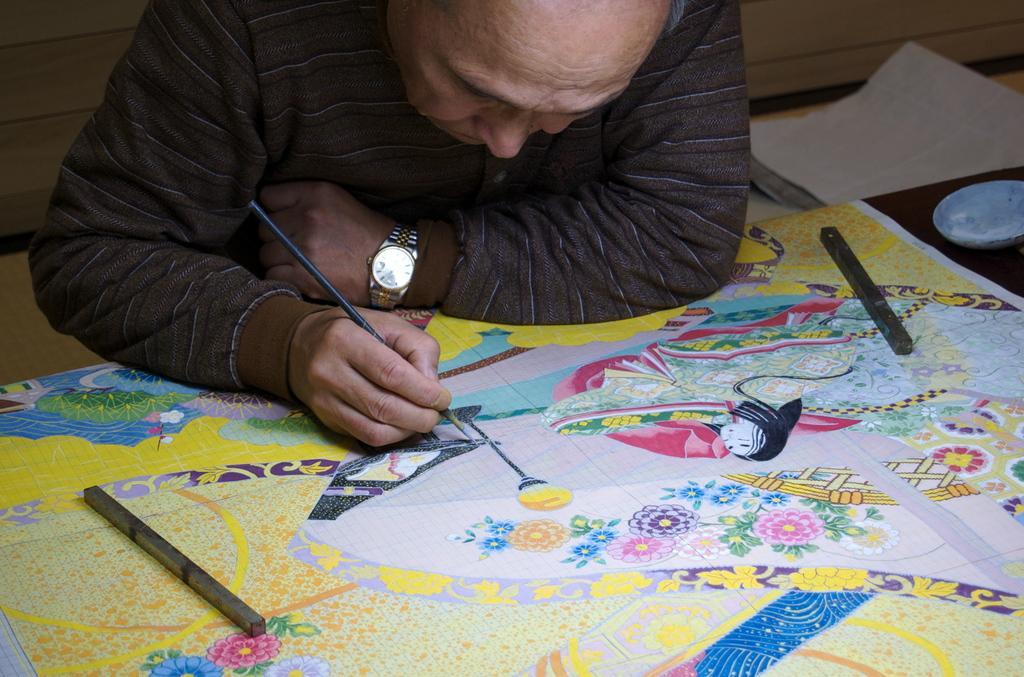How would you summarize this image in a sentence or two? In this image there is a man, he is drawing a picture on a sheet. 